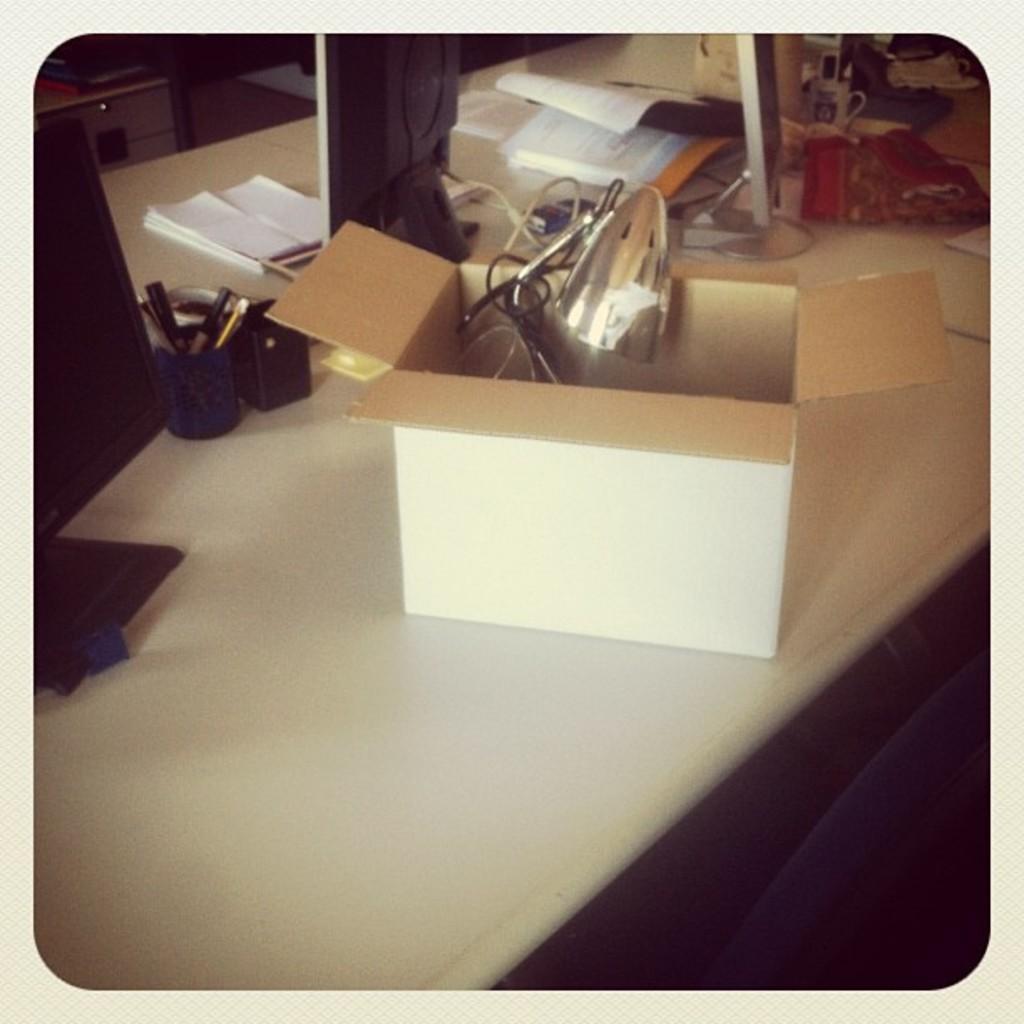Please provide a concise description of this image. In this image we can see a table on which there is a cardboard box. There is a pen stand. There is a monitor and there are books. There are other objects. 